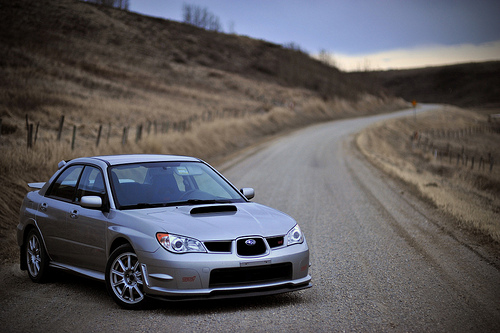<image>
Is there a post to the left of the road? Yes. From this viewpoint, the post is positioned to the left side relative to the road. 